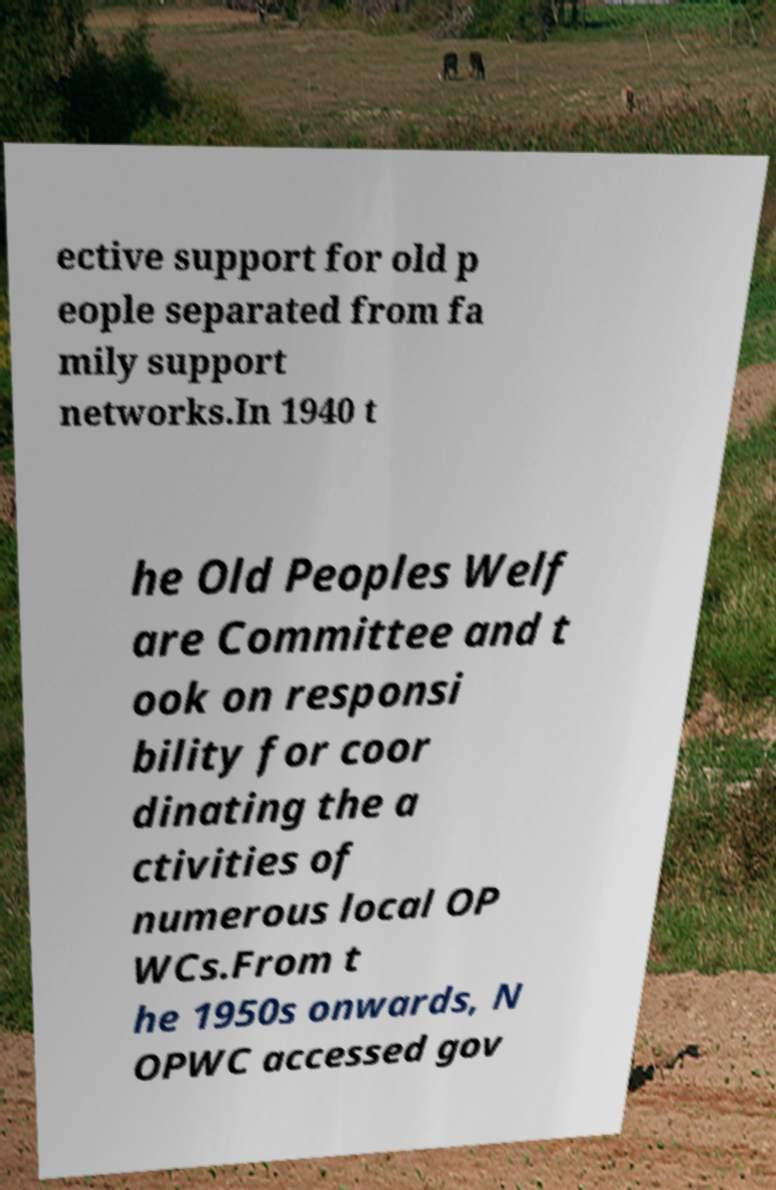Can you accurately transcribe the text from the provided image for me? ective support for old p eople separated from fa mily support networks.In 1940 t he Old Peoples Welf are Committee and t ook on responsi bility for coor dinating the a ctivities of numerous local OP WCs.From t he 1950s onwards, N OPWC accessed gov 